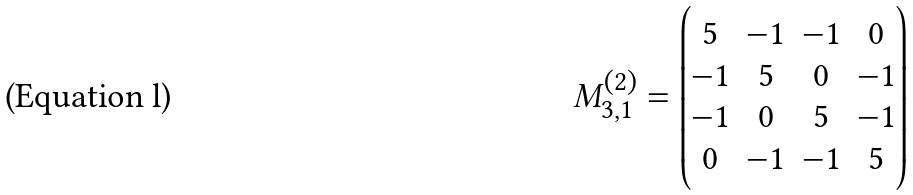Convert formula to latex. <formula><loc_0><loc_0><loc_500><loc_500>M _ { 3 , 1 } ^ { ( 2 ) } = \begin{pmatrix} 5 & - 1 & - 1 & 0 \\ - 1 & 5 & 0 & - 1 \\ - 1 & 0 & 5 & - 1 \\ 0 & - 1 & - 1 & 5 \end{pmatrix}</formula> 